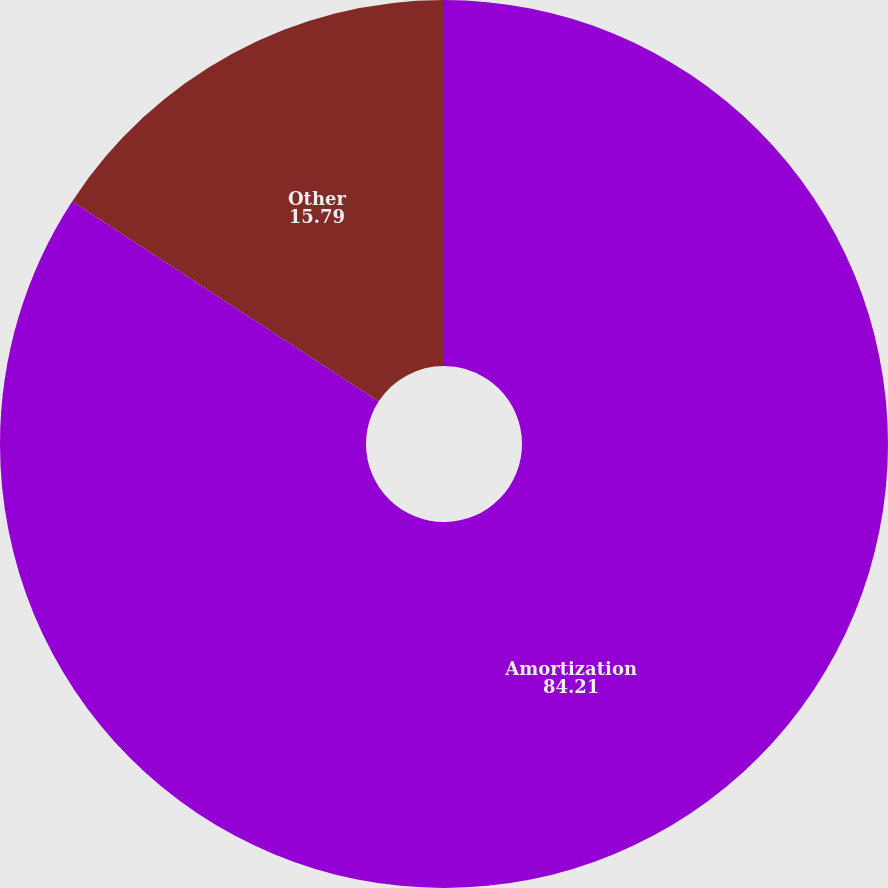Convert chart to OTSL. <chart><loc_0><loc_0><loc_500><loc_500><pie_chart><fcel>Amortization<fcel>Other<nl><fcel>84.21%<fcel>15.79%<nl></chart> 